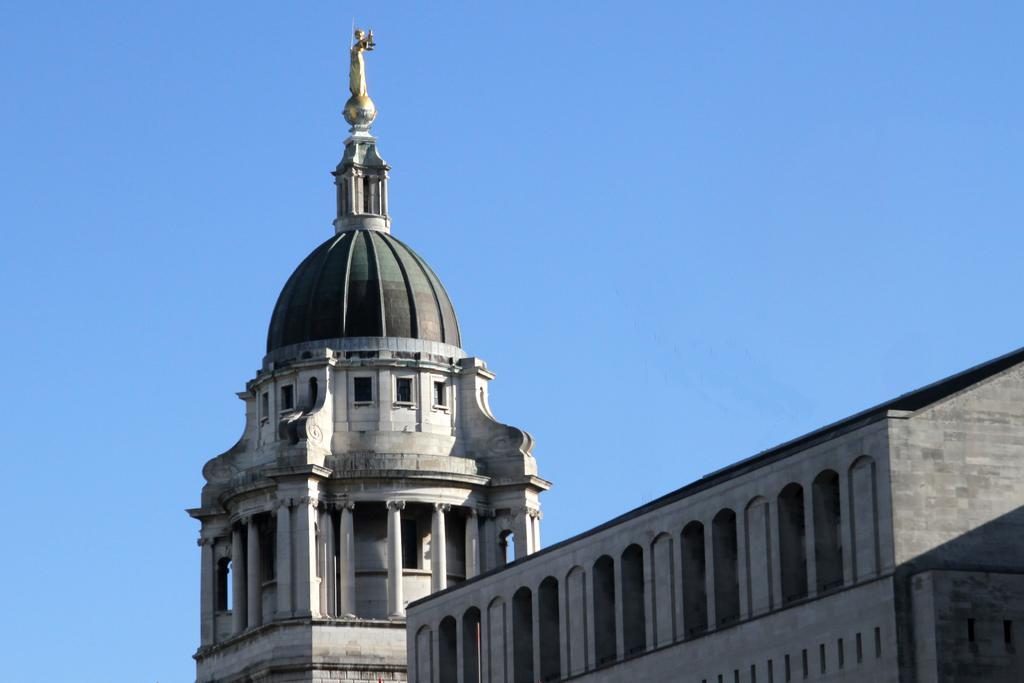Can you describe this image briefly? In this image I can see a building in white and gray color, background the sky is in blue color. 